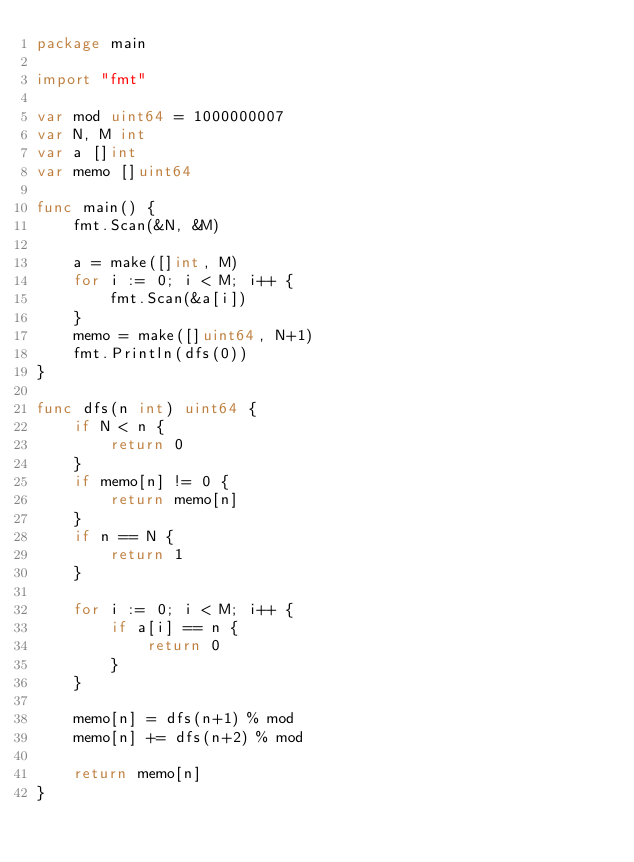Convert code to text. <code><loc_0><loc_0><loc_500><loc_500><_Go_>package main

import "fmt"

var mod uint64 = 1000000007
var N, M int
var a []int
var memo []uint64

func main() {
	fmt.Scan(&N, &M)

	a = make([]int, M)
	for i := 0; i < M; i++ {
		fmt.Scan(&a[i])
	}
	memo = make([]uint64, N+1)
	fmt.Println(dfs(0))
}

func dfs(n int) uint64 {
	if N < n {
		return 0
	}
	if memo[n] != 0 {
		return memo[n]
	}
	if n == N {
		return 1
	}

	for i := 0; i < M; i++ {
		if a[i] == n {
			return 0
		}
	}

	memo[n] = dfs(n+1) % mod
	memo[n] += dfs(n+2) % mod

	return memo[n]
}
</code> 